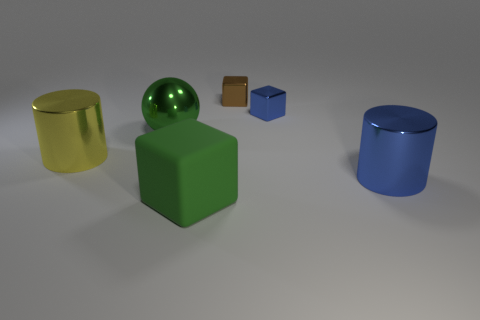Is there anything else that has the same material as the big cube?
Offer a terse response. No. Do the tiny blue thing and the tiny brown object have the same shape?
Your answer should be compact. Yes. Does the green object in front of the shiny sphere have the same shape as the tiny blue thing?
Your answer should be compact. Yes. What is the blue thing that is behind the green shiny thing made of?
Provide a short and direct response. Metal. The big shiny object that is the same color as the large rubber thing is what shape?
Your response must be concise. Sphere. What number of yellow objects are either small metallic objects or big matte cubes?
Keep it short and to the point. 0. How many blue metal objects have the same shape as the large yellow object?
Your answer should be very brief. 1. How many metallic spheres are the same size as the green rubber block?
Provide a succinct answer. 1. What is the material of the large green object that is the same shape as the small brown shiny object?
Ensure brevity in your answer.  Rubber. The tiny shiny thing behind the blue metallic cube is what color?
Ensure brevity in your answer.  Brown. 